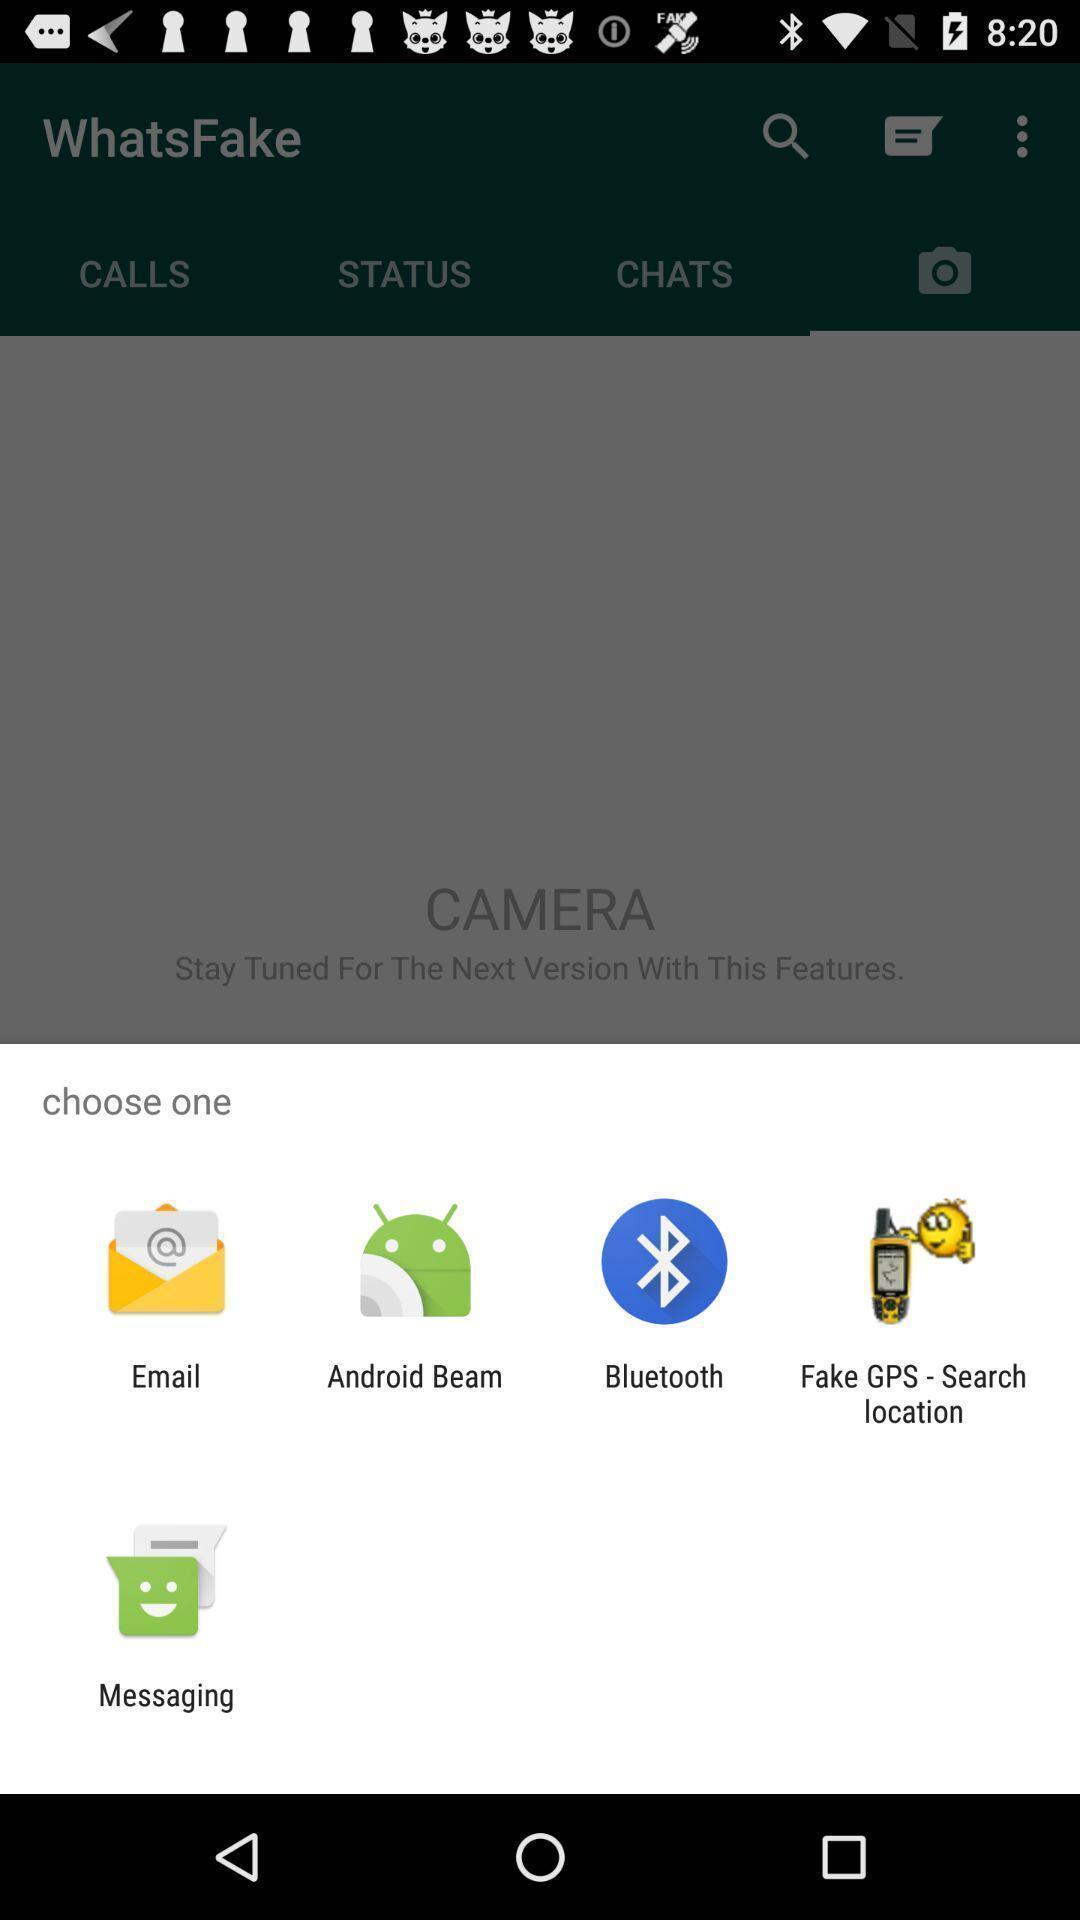Provide a detailed account of this screenshot. Pop-up showing the multiple share options. 